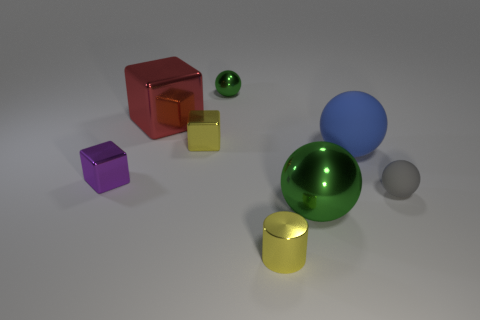Add 2 yellow metal cubes. How many objects exist? 10 Subtract all cylinders. How many objects are left? 7 Add 3 tiny red spheres. How many tiny red spheres exist? 3 Subtract 0 blue blocks. How many objects are left? 8 Subtract all small gray rubber objects. Subtract all big purple rubber cylinders. How many objects are left? 7 Add 3 green spheres. How many green spheres are left? 5 